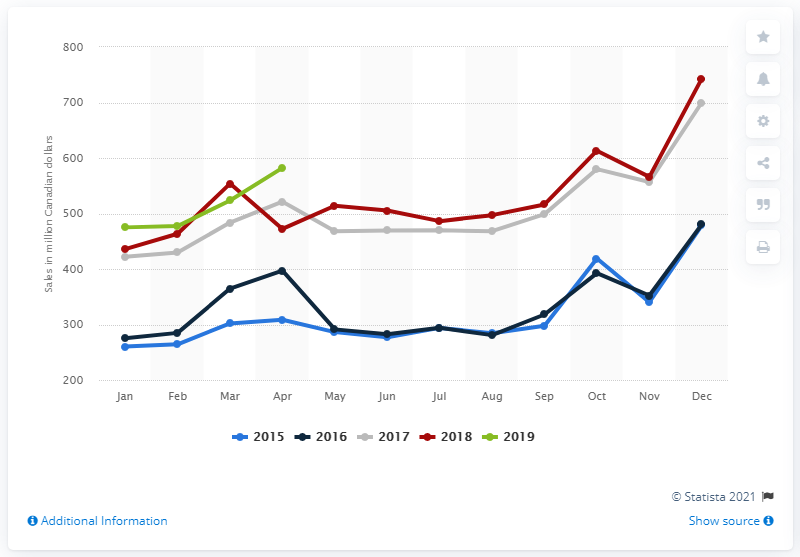Mention a couple of crucial points in this snapshot. In April 2019, the total amount of retail sales of candy, confectionery, and snack foods at large retailers in Canada was CAD 580.05. 